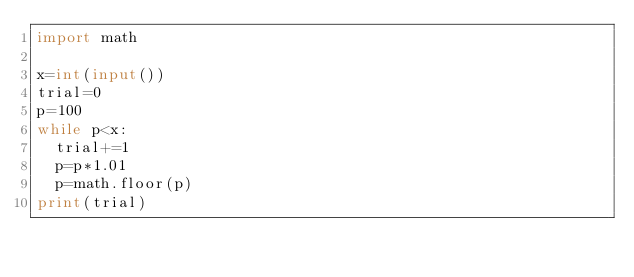Convert code to text. <code><loc_0><loc_0><loc_500><loc_500><_Python_>import math

x=int(input())
trial=0
p=100
while p<x:
  trial+=1
  p=p*1.01
  p=math.floor(p)
print(trial)
</code> 